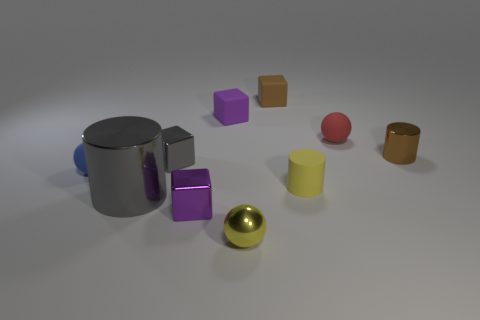What is the material of the ball that is the same color as the rubber cylinder?
Make the answer very short. Metal. How many other things are made of the same material as the tiny red thing?
Give a very brief answer. 4. What shape is the small thing that is the same color as the large shiny object?
Provide a succinct answer. Cube. What size is the cylinder left of the tiny yellow metallic object?
Make the answer very short. Large. What shape is the yellow object that is the same material as the red ball?
Give a very brief answer. Cylinder. Is the material of the brown cylinder the same as the small ball that is behind the small blue rubber thing?
Offer a terse response. No. There is a small matte object on the left side of the tiny purple matte cube; is its shape the same as the yellow matte thing?
Offer a terse response. No. There is a gray thing that is the same shape as the brown metal thing; what material is it?
Give a very brief answer. Metal. Does the large gray thing have the same shape as the small rubber object in front of the blue matte sphere?
Keep it short and to the point. Yes. The tiny matte thing that is both right of the large metallic cylinder and on the left side of the shiny ball is what color?
Your answer should be compact. Purple. 